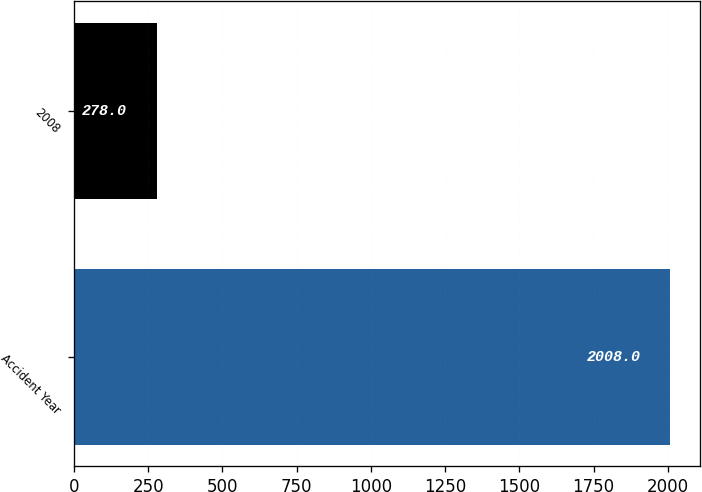Convert chart to OTSL. <chart><loc_0><loc_0><loc_500><loc_500><bar_chart><fcel>Accident Year<fcel>2008<nl><fcel>2008<fcel>278<nl></chart> 